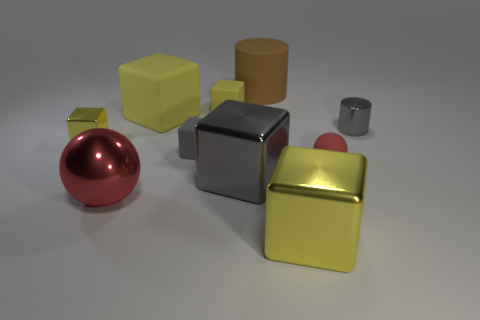What number of big rubber cylinders are on the left side of the tiny matte block that is in front of the gray object that is on the right side of the brown matte thing? There are no big rubber cylinders located on the left side of the tiny matte block in front of the gray object, which in turn is on the right side of the brown matte thing. The left side of the tiny block, from this perspective, is clear of any large cylinders. 